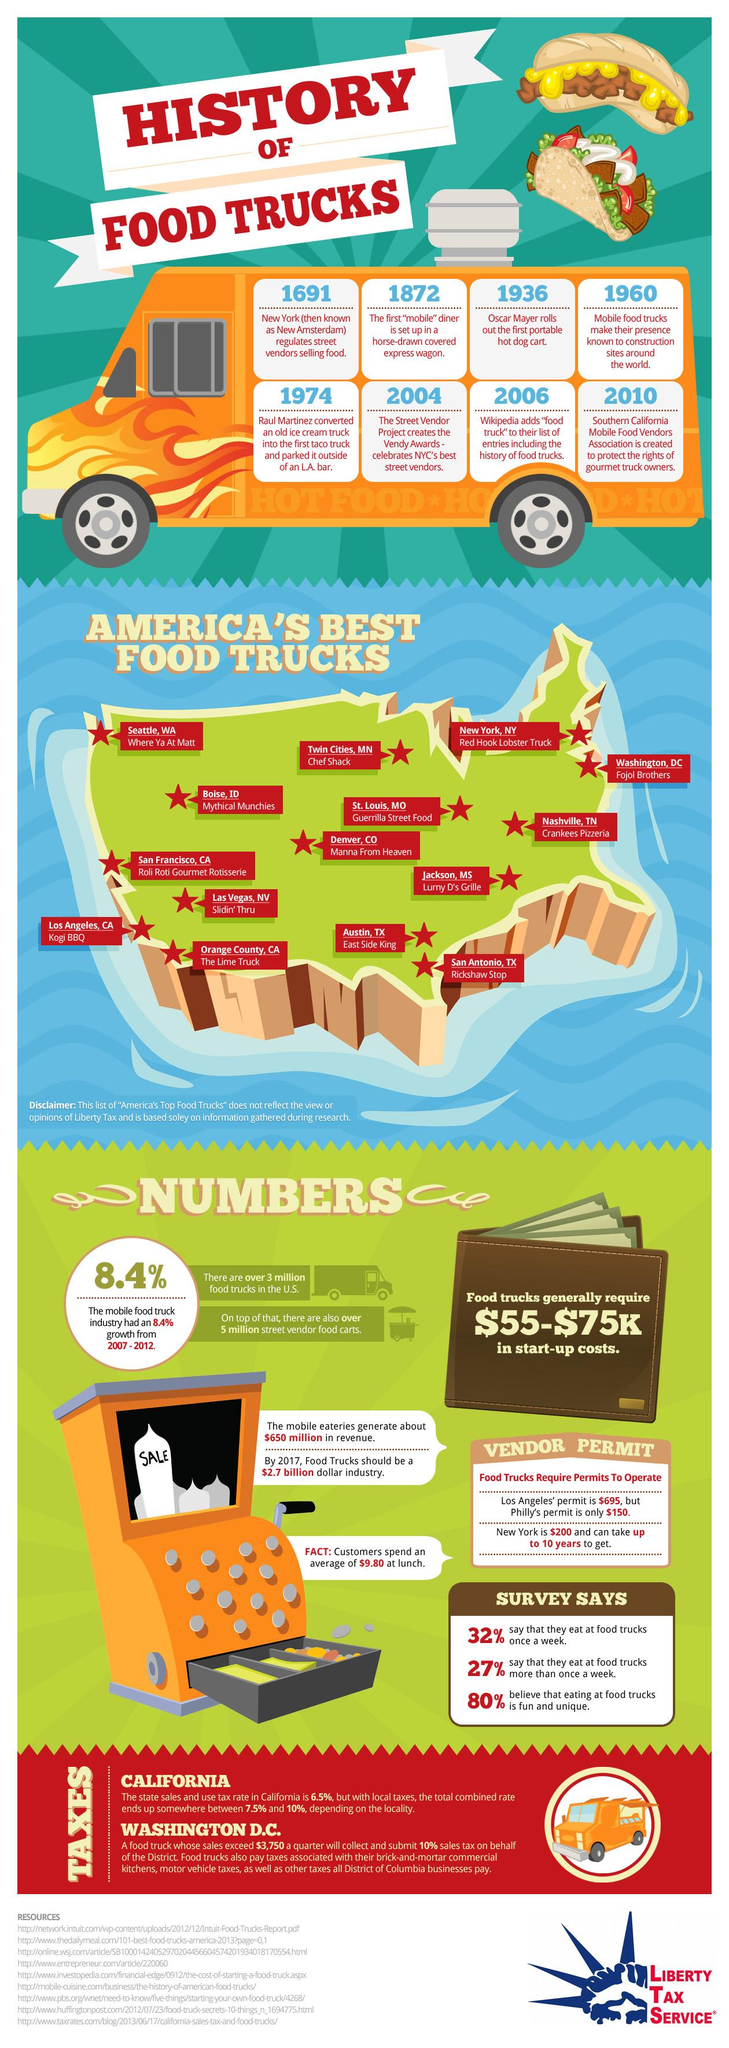Draw attention to some important aspects in this diagram. In 2004, awards were established for vendors selling food on the street. According to a count of America's best food trucks, the number is 15. Raul Martinez was instrumental in introducing food trucks to the United States. East Side King and Rickshaw Stop are considered to be the best food trucks in Texas, offering a diverse selection of delicious and unique dishes that have gained widespread popularity among foodies and locals alike. The first food sold using mobile carts was hot dogs. Specifically, hot dogs were the first food item that was marketed and sold through mobile carts, such as ice cream, tacos, or other street foods. 